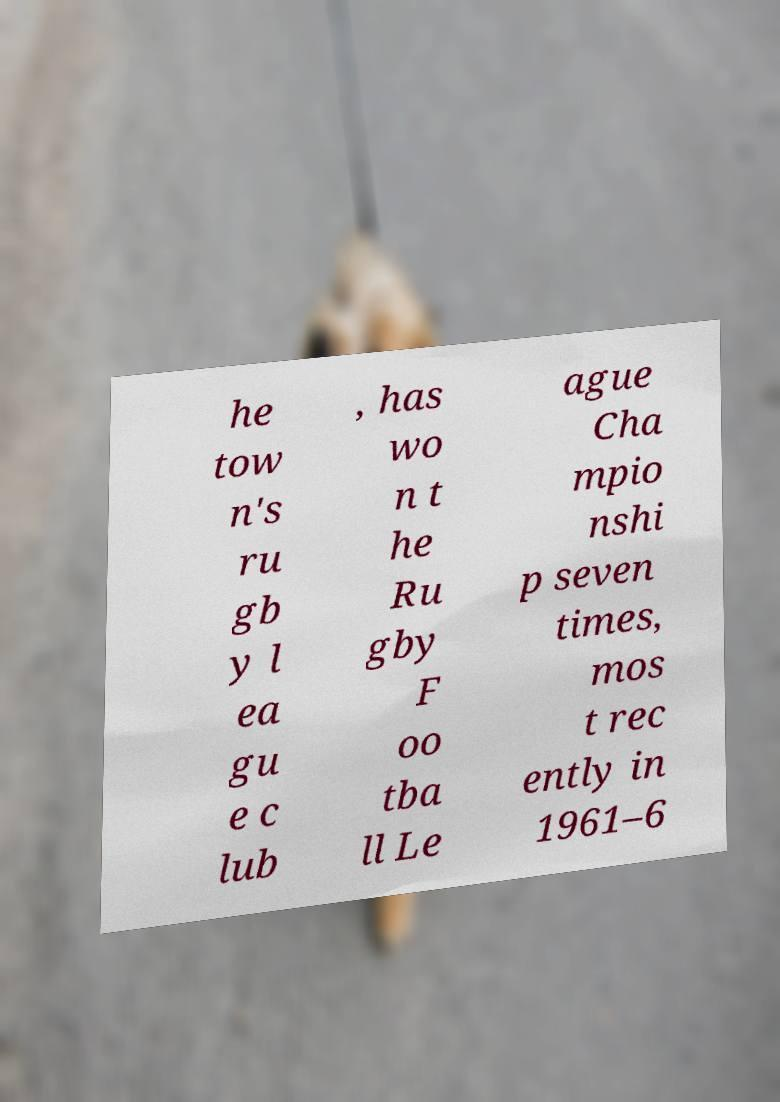Please identify and transcribe the text found in this image. he tow n's ru gb y l ea gu e c lub , has wo n t he Ru gby F oo tba ll Le ague Cha mpio nshi p seven times, mos t rec ently in 1961–6 